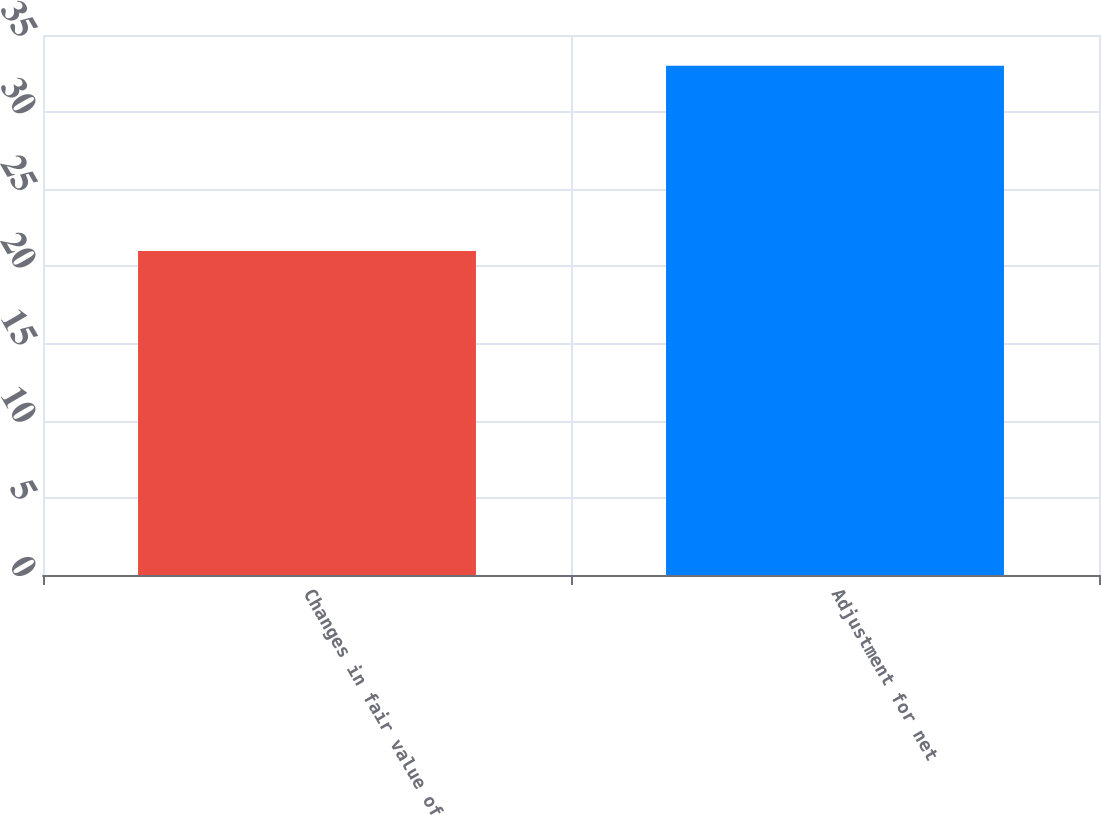Convert chart. <chart><loc_0><loc_0><loc_500><loc_500><bar_chart><fcel>Changes in fair value of<fcel>Adjustment for net<nl><fcel>21<fcel>33<nl></chart> 